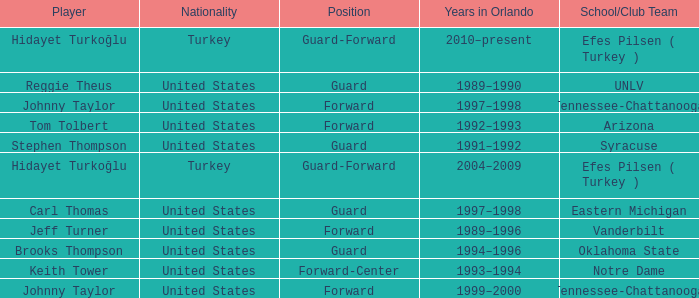What is the Position of the player from Vanderbilt? Forward. 